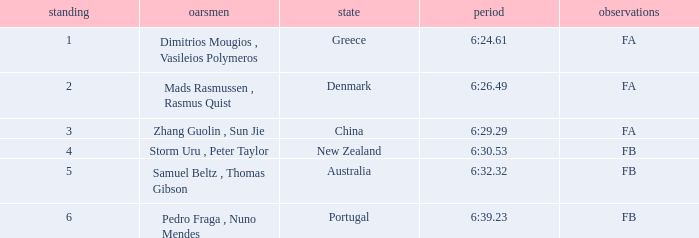What is the rank of the time of 6:30.53? 1.0. 